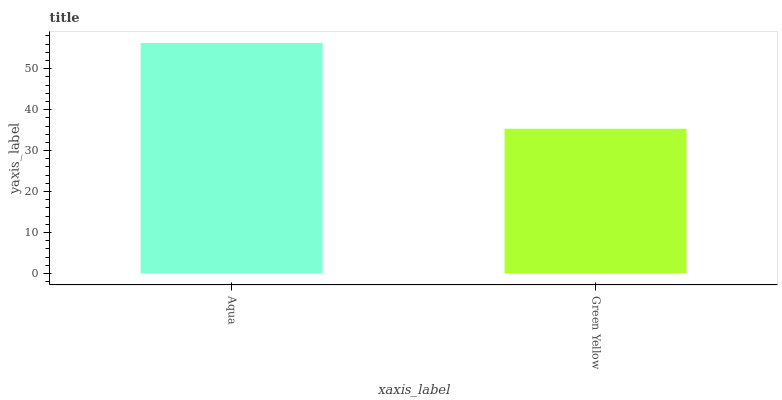Is Green Yellow the maximum?
Answer yes or no. No. Is Aqua greater than Green Yellow?
Answer yes or no. Yes. Is Green Yellow less than Aqua?
Answer yes or no. Yes. Is Green Yellow greater than Aqua?
Answer yes or no. No. Is Aqua less than Green Yellow?
Answer yes or no. No. Is Aqua the high median?
Answer yes or no. Yes. Is Green Yellow the low median?
Answer yes or no. Yes. Is Green Yellow the high median?
Answer yes or no. No. Is Aqua the low median?
Answer yes or no. No. 